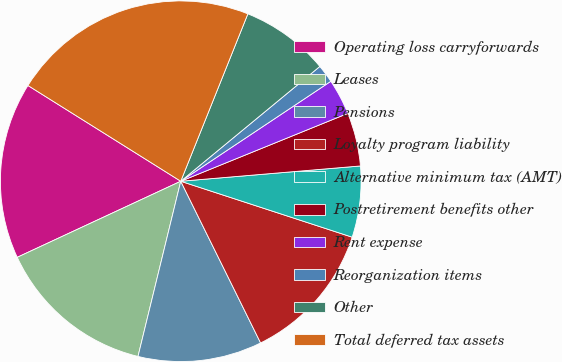Convert chart to OTSL. <chart><loc_0><loc_0><loc_500><loc_500><pie_chart><fcel>Operating loss carryforwards<fcel>Leases<fcel>Pensions<fcel>Loyalty program liability<fcel>Alternative minimum tax (AMT)<fcel>Postretirement benefits other<fcel>Rent expense<fcel>Reorganization items<fcel>Other<fcel>Total deferred tax assets<nl><fcel>15.84%<fcel>14.26%<fcel>11.11%<fcel>12.68%<fcel>6.37%<fcel>4.79%<fcel>3.21%<fcel>1.63%<fcel>7.95%<fcel>22.16%<nl></chart> 